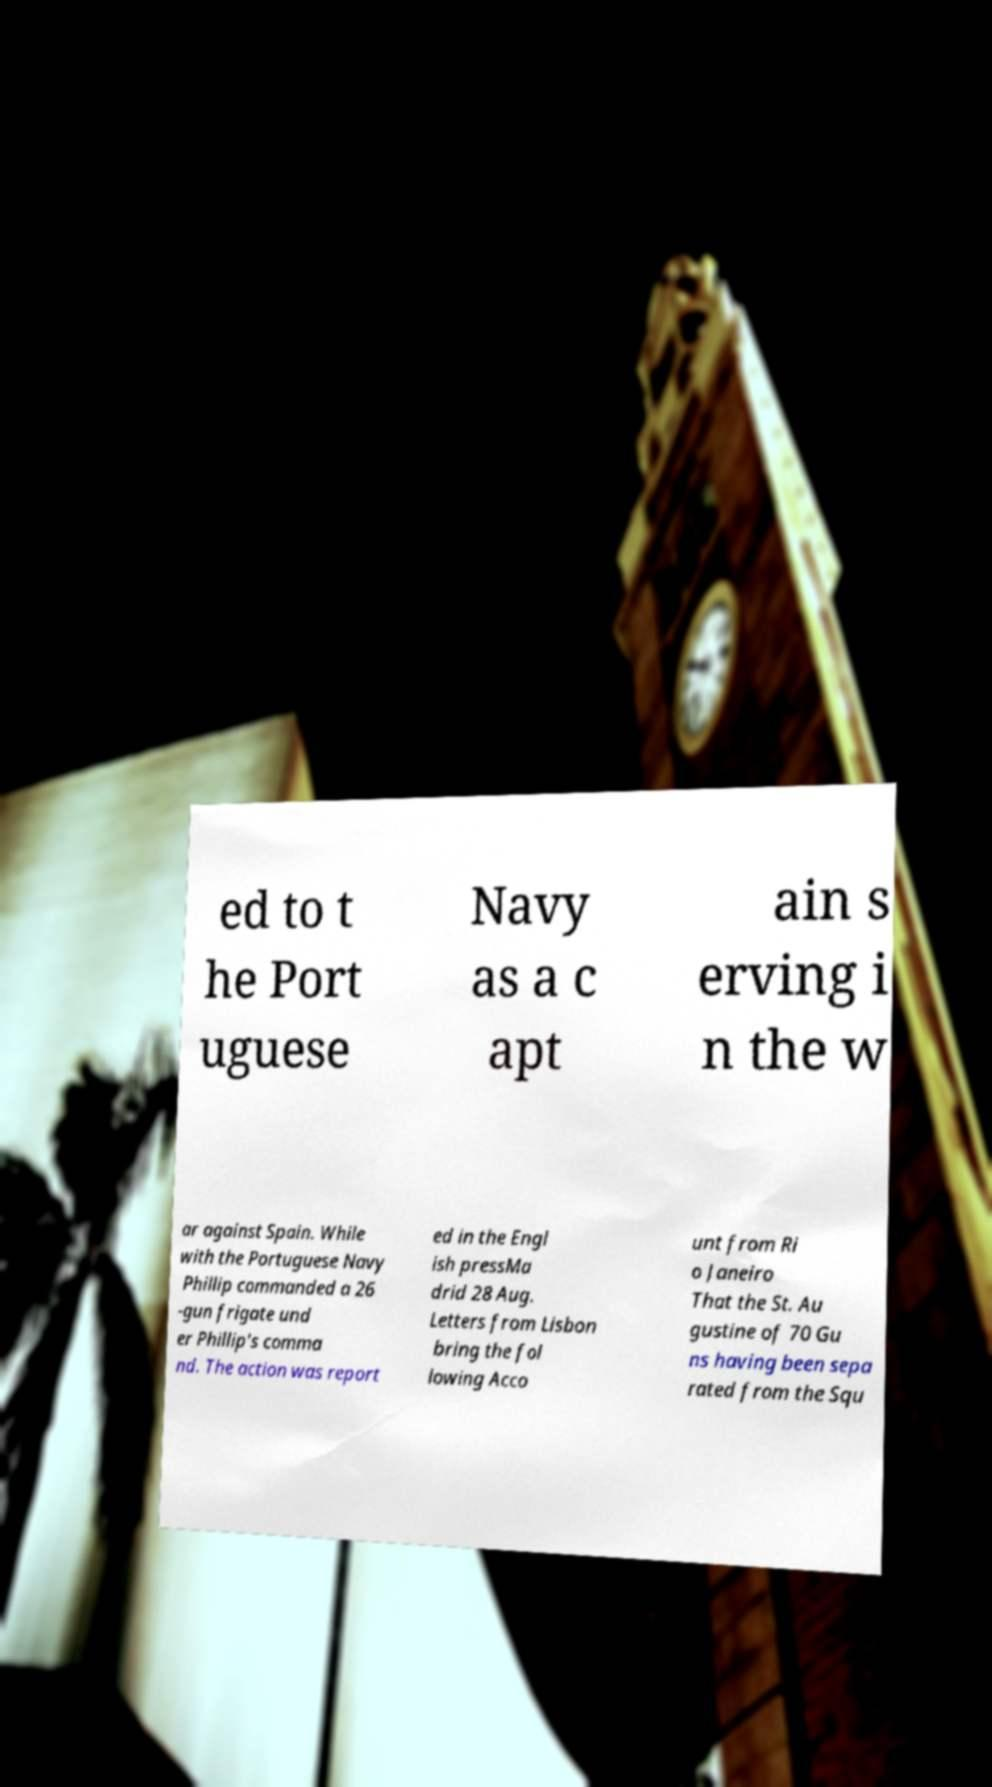Could you extract and type out the text from this image? ed to t he Port uguese Navy as a c apt ain s erving i n the w ar against Spain. While with the Portuguese Navy Phillip commanded a 26 -gun frigate und er Phillip's comma nd. The action was report ed in the Engl ish pressMa drid 28 Aug. Letters from Lisbon bring the fol lowing Acco unt from Ri o Janeiro That the St. Au gustine of 70 Gu ns having been sepa rated from the Squ 